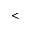<formula> <loc_0><loc_0><loc_500><loc_500><</formula> 